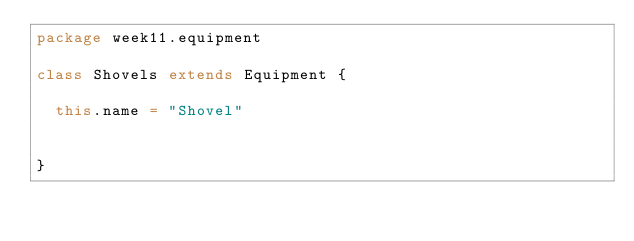<code> <loc_0><loc_0><loc_500><loc_500><_Scala_>package week11.equipment

class Shovels extends Equipment {

  this.name = "Shovel"


}
</code> 